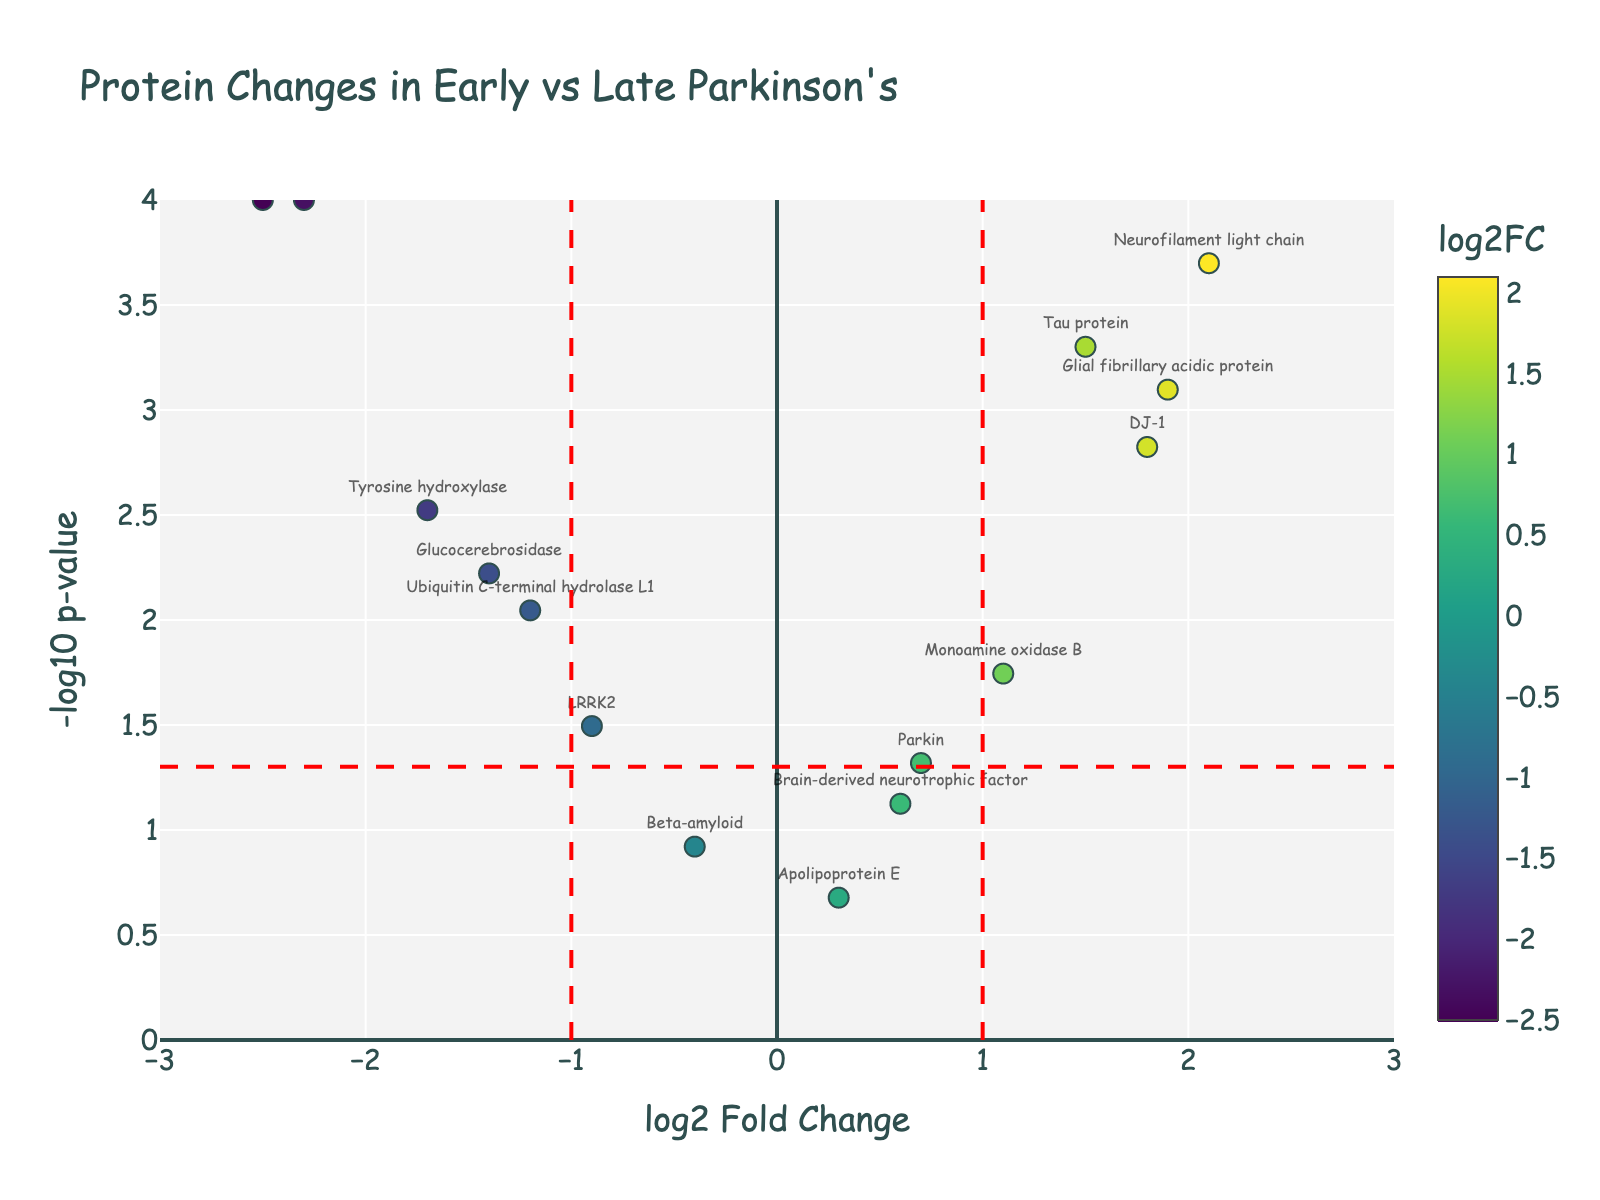What is the title of the plot? The title of the plot is usually displayed at the top of the figure. In this case, it is directly taken from the plot's layout settings.
Answer: Protein Changes in Early vs. Late Parkinson's What do the x-axis and y-axis represent? The x-axis title is given as "log2 Fold Change," and the y-axis title is given as "-log10 p-value," which are displayed below and beside their respective axes.
Answer: x-axis: log2 Fold Change, y-axis: -log10 p-value How many proteins have a log2FoldChange greater than zero? Count the number of points that lie to the right of the y-axis (log2FoldChange > 0). There are 8 such points.
Answer: 8 Which protein has the highest p-value? The p-value is inversely related to the y-axis value (-log10 p-value). The protein with the lowest y-axis value (closest to 0 on the y-axis) has the highest p-value. This is Beta-amyloid.
Answer: Beta-amyloid Which protein shows the greatest down-regulation in late-stage Parkinson's patients? The greatest down-regulation corresponds to the most negative log2FoldChange. The protein with the lowest x-axis value (most negative) is the Dopamine transporter.
Answer: Dopamine transporter What threshold value is represented by the red dashed lines on the x-axis? The red dashed lines on the x-axis are positioned at -1 and 1, representing the threshold values for significant fold changes.
Answer: -1 and 1 How many proteins show statistically significant changes (p-value < 0.05)? To determine statistical significance, look for points above the horizontal red dashed line (-log10(0.05) ≈ 1.3). Count these points. There are 12 such proteins.
Answer: 12 Which protein has the highest -log10 p-value, indicating the most statistically significant difference? The highest -log10 p-value corresponds to the highest point on the y-axis. The protein at this point is Alpha-synuclein.
Answer: Alpha-synuclein 